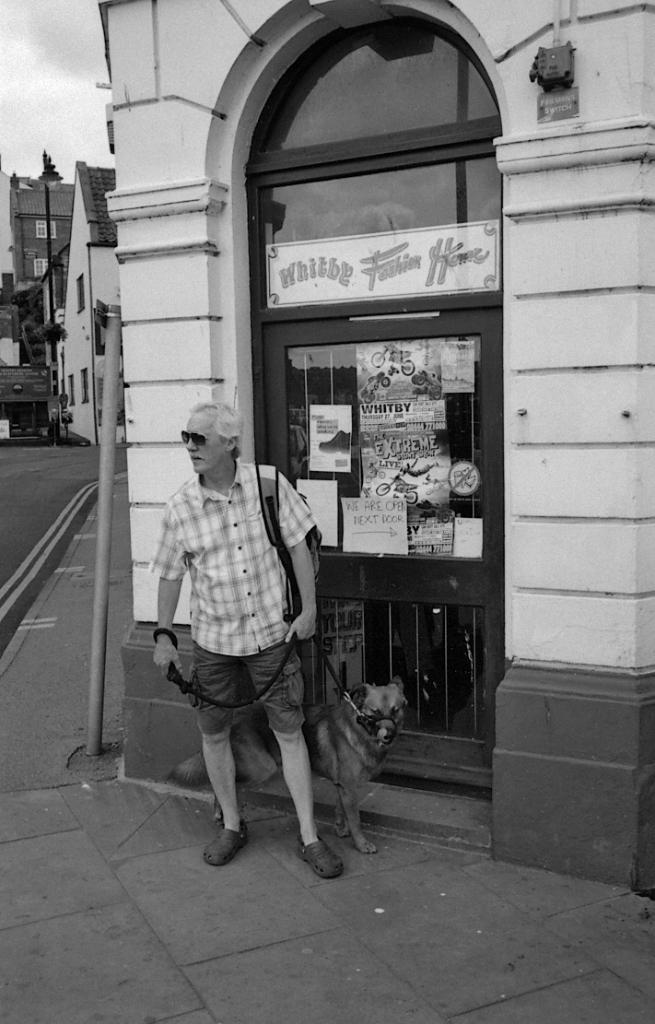Can you describe this image briefly? A person is holding belt tied to a dog. Behind him there is a building and posters on a door. On the left there are buildings and trees. 